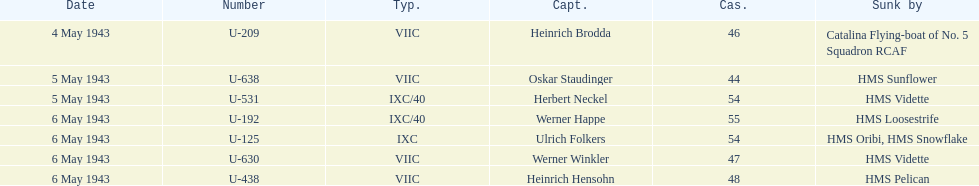Which u-boat was the first to sink U-209. 